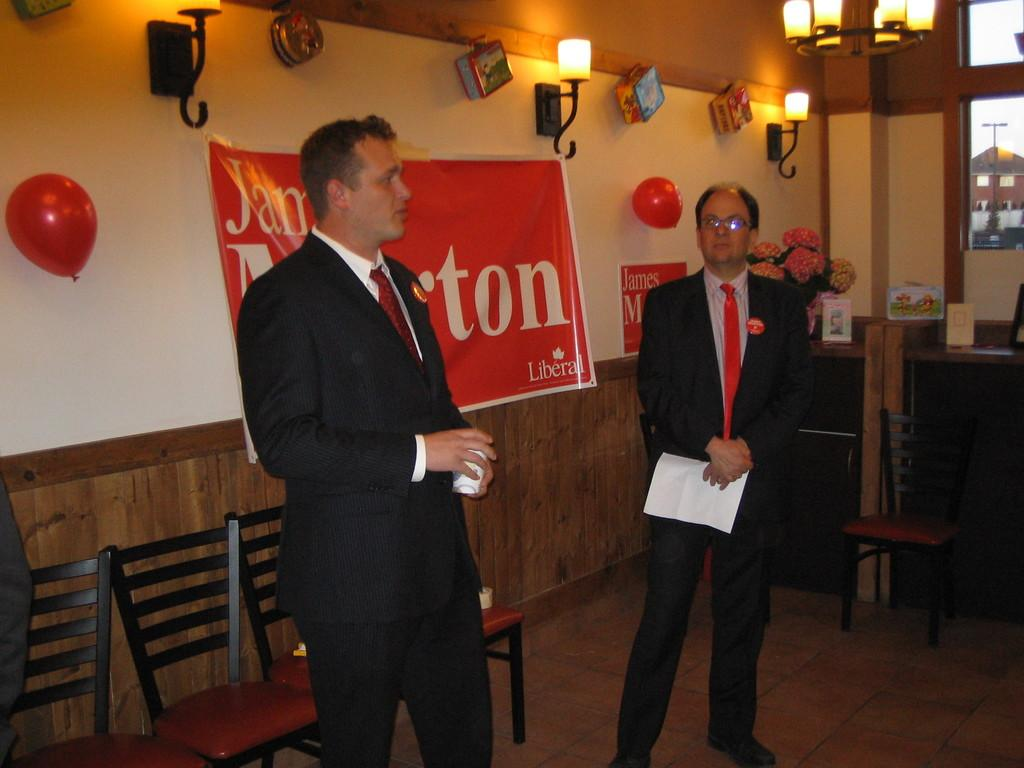How many people are present in the image? There are two men standing in the image. What objects are visible in the image that people might sit on? Chairs are visible in the image. What is hanging on the wall in the image? There is a banner on a wall in the image. What type of lighting is present in the image? There are lights visible in the image. What decorative items can be seen in the image? There are balloons in the image. Can you tell me the color of the pen that the woman is holding in the image? There is no woman present in the image, nor is there a pen visible. 